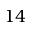<formula> <loc_0><loc_0><loc_500><loc_500>1 4</formula> 